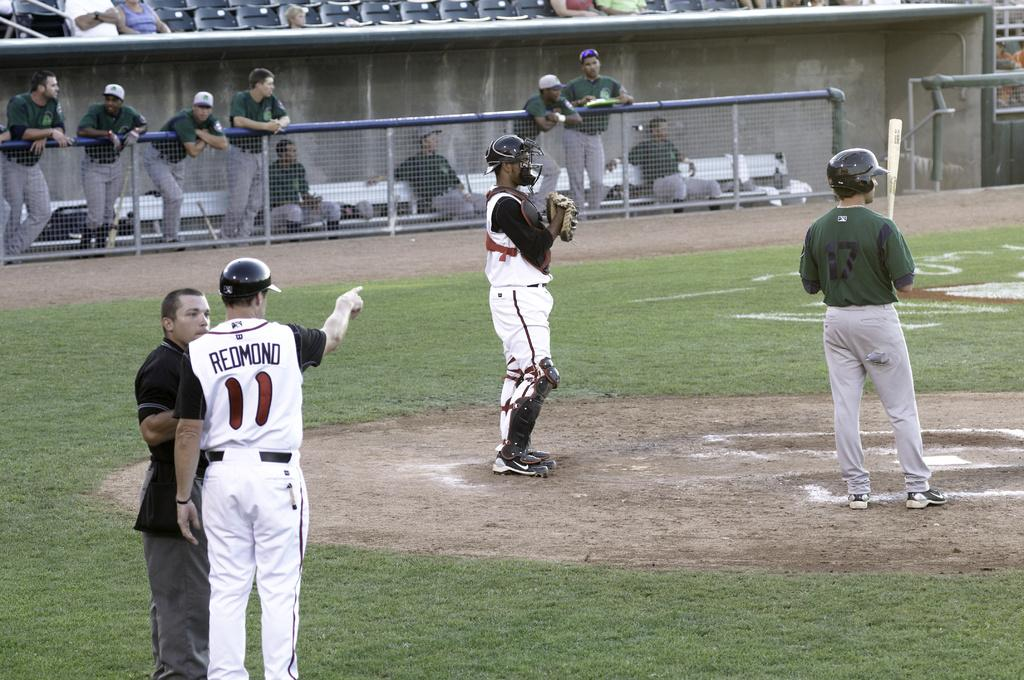<image>
Share a concise interpretation of the image provided. A baseball player wearing a jersey with the name Redmond on the back points at the home plate. 